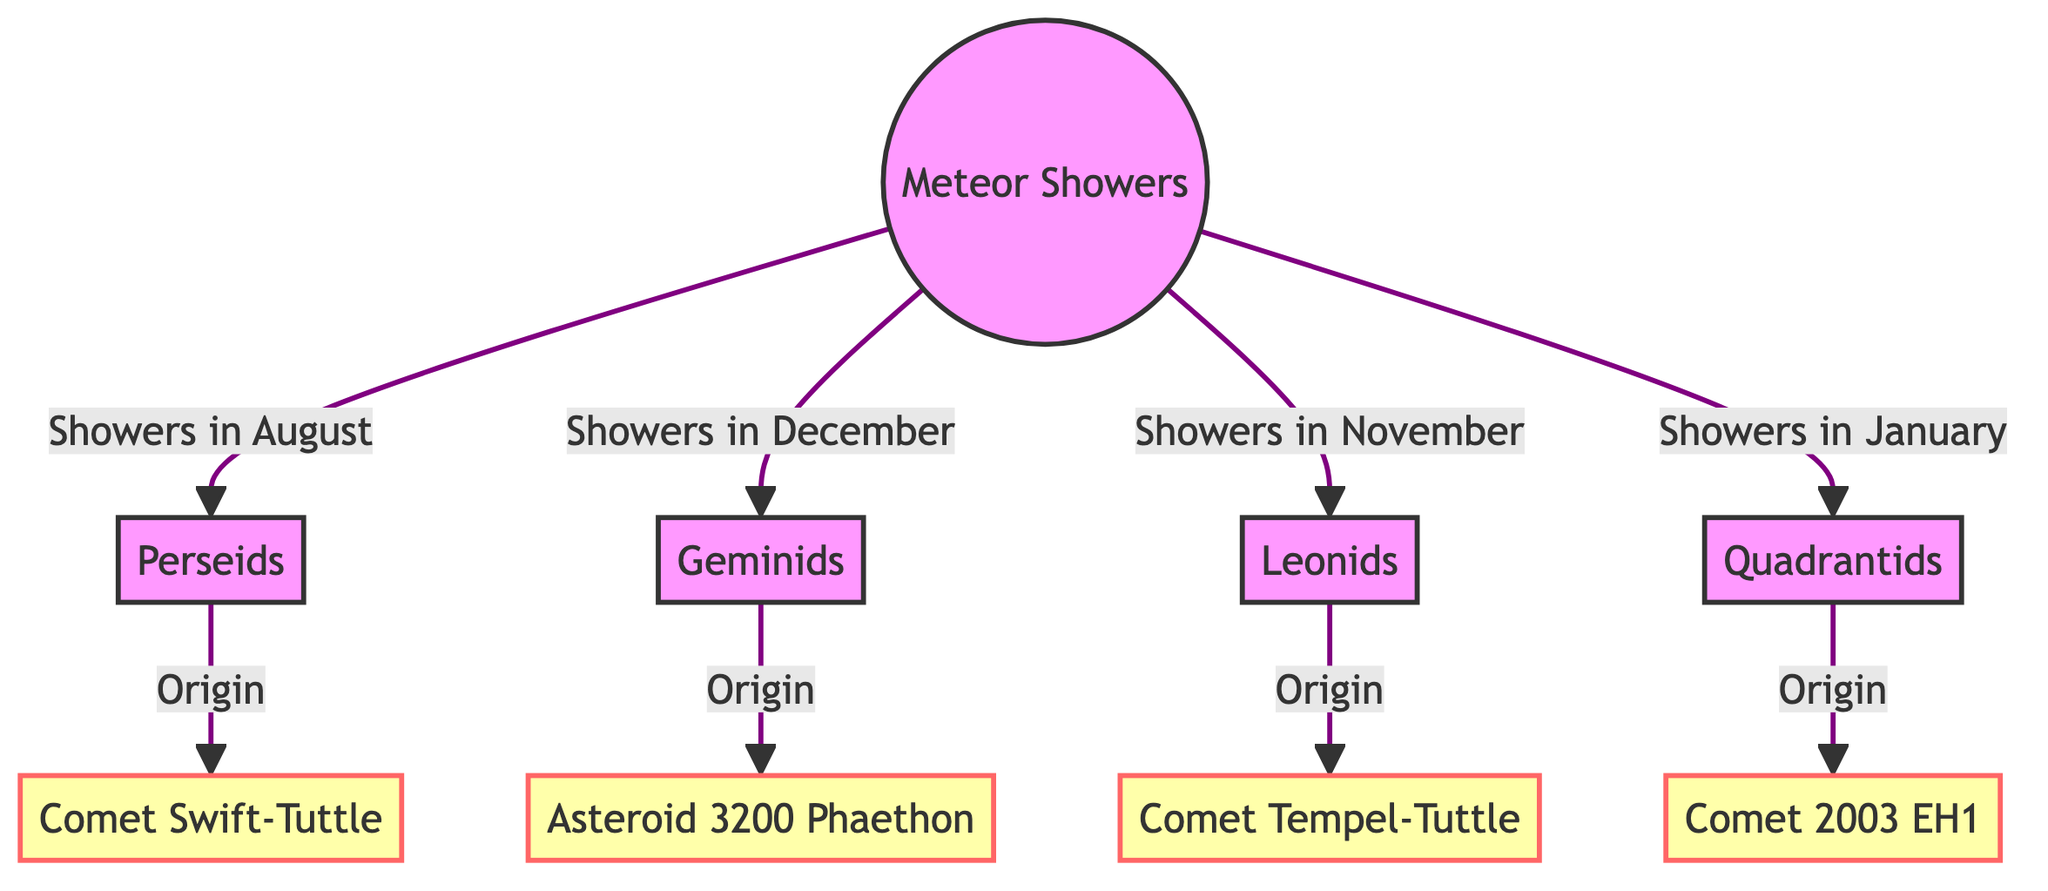What is the origin of the Perseids meteor shower? The diagram shows an arrow pointing from the Perseids to Comet Swift-Tuttle, indicating that this comet is the origin of the Perseids meteor shower.
Answer: Comet Swift-Tuttle How many meteor showers are listed in the diagram? By counting the nodes directly related to "Meteor Showers," we see there are four meteor showers identified: Perseids, Geminids, Leonids, and Quadrantids.
Answer: 4 Which meteor shower originates from Asteroid 3200 Phaethon? The diagram indicates an arrow leading from Geminids to Asteroid 3200 Phaethon, showing that the Geminids meteor shower originates from this asteroid.
Answer: Geminids During which month do the Leonids meteor showers occur? The diagram specifies that Leonids are associated with "Showers in November," identifying November as the month for this meteor shower.
Answer: November What is the relationship between Quadrantids and Comet 2003 EH1? The diagram depicts an arrow from Quadrantids to Comet 2003 EH1, indicating that Comet 2003 EH1 is the origin of the Quadrantids meteor shower.
Answer: Origin Which meteor shower is associated with the month of August? The flowchart directly links Perseids to "Showers in August," making it clear that this meteor shower occurs in August.
Answer: Perseids How many celestial origins are mentioned in the diagram? By reviewing the origins linked to the four meteor showers, we can enumerate them and find there are four distinct celestial origins: Comet Swift-Tuttle, Asteroid 3200 Phaethon, Comet Tempel-Tuttle, and Comet 2003 EH1.
Answer: 4 What color is used for the main node "Meteor Showers"? The diagram visually represents the main node "Meteor Showers" with a fill color described as #f96, which indicates a specific shade in the diagram.
Answer: #f96 Which meteor shower is related to Comet Tempel-Tuttle? The diagram shows a connection where Leonids lead to Comet Tempel-Tuttle, indicating that Comet Tempel-Tuttle is the origin for the Leonids meteor shower.
Answer: Leonids 